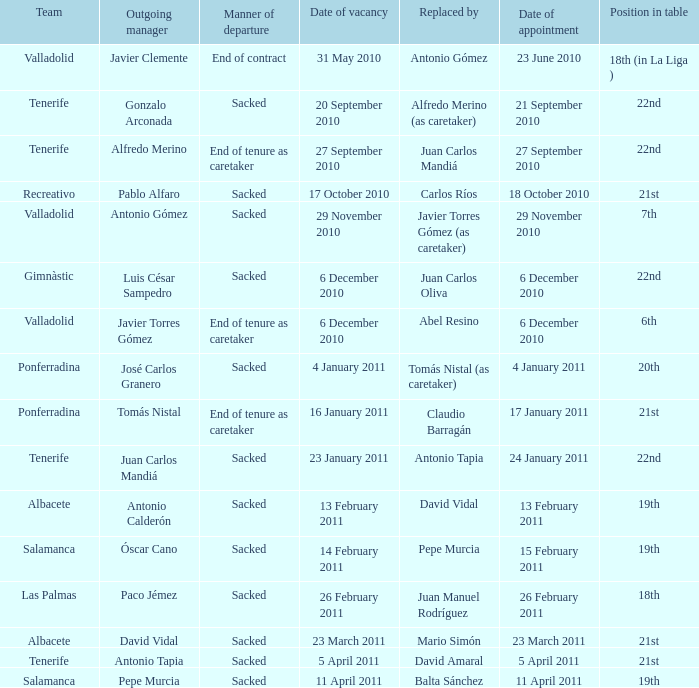What was the manner of departure for the appointment date of 21 september 2010 Sacked. 